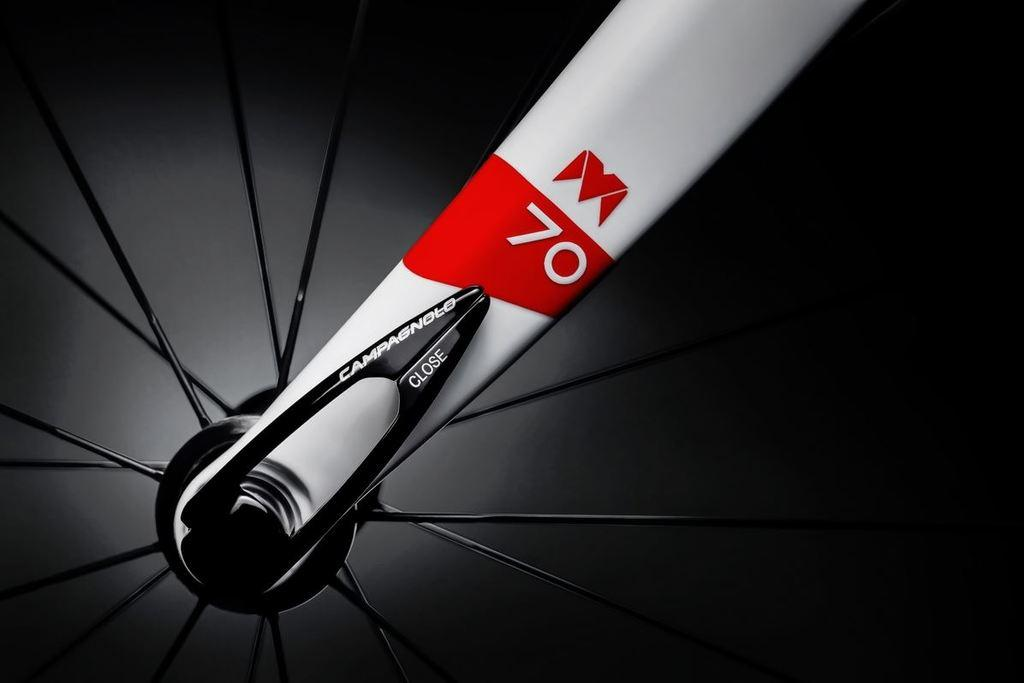What can be seen in the image related to a cycle? There are cycle spokes in the image. What is the color of the cycle spokes? The cycle spokes are black in color. What else is present in the image besides the cycle spokes? There is a red and white color rod in the image. What is written on the rod? Something is written on the rod, but the specific text cannot be determined from the image. Where is the cannon located in the image? There is no cannon present in the image. What type of mask is hanging on the wall in the image? There is no mask or wall present in the image; it only features cycle spokes and a red and white color rod. 